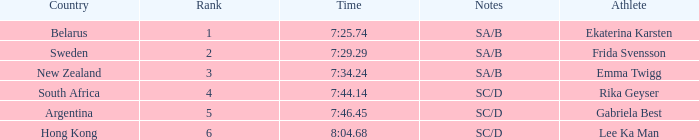What country is the athlete ekaterina karsten from with a rank less than 4? Belarus. 